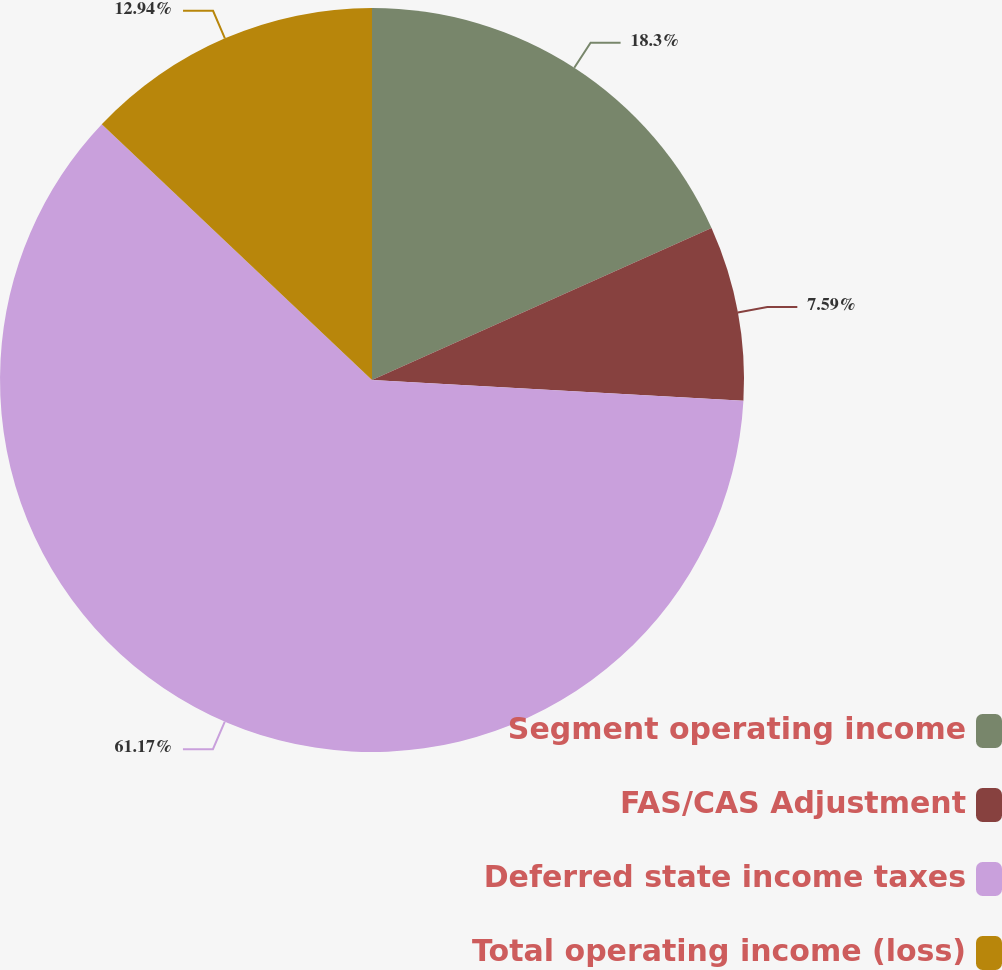<chart> <loc_0><loc_0><loc_500><loc_500><pie_chart><fcel>Segment operating income<fcel>FAS/CAS Adjustment<fcel>Deferred state income taxes<fcel>Total operating income (loss)<nl><fcel>18.3%<fcel>7.59%<fcel>61.17%<fcel>12.94%<nl></chart> 